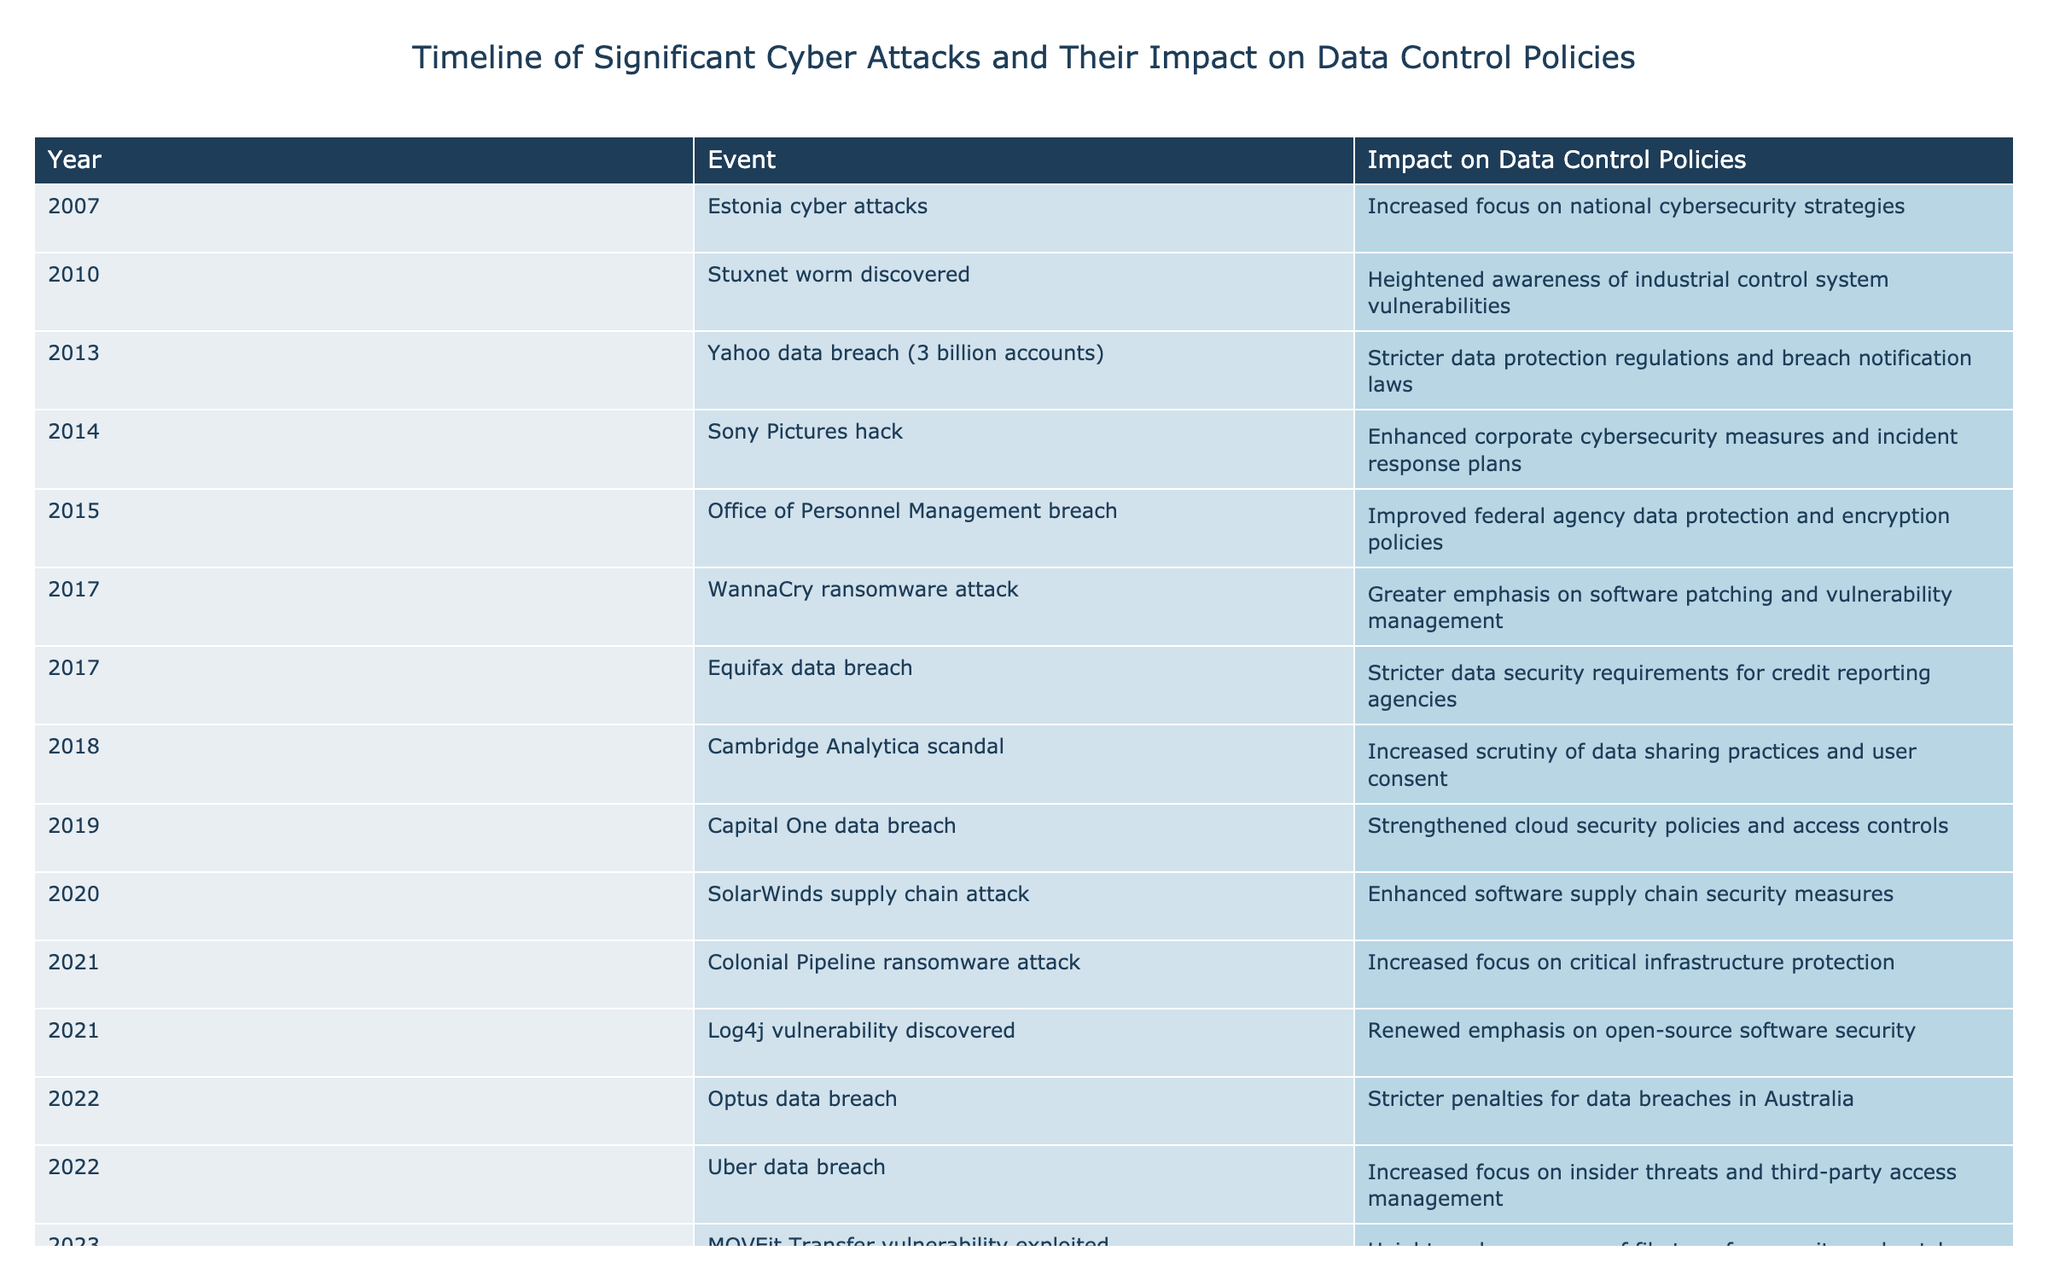What year did the Equifax data breach occur? The table directly lists the year associated with the Equifax data breach, which is 2017.
Answer: 2017 What impact did the Colonial Pipeline ransomware attack have on data control policies? The table states that the impact of the Colonial Pipeline ransomware attack in 2021 was an increased focus on critical infrastructure protection.
Answer: Increased focus on critical infrastructure protection Which event in 2018 led to increased scrutiny of data sharing practices? The table notes that the Cambridge Analytica scandal in 2018 is the event that led to increased scrutiny of data sharing practices and user consent.
Answer: Cambridge Analytica scandal How many events are listed for the year 2017? By counting the occurrences in the table, there are two events listed for 2017: the WannaCry ransomware attack and the Equifax data breach.
Answer: 2 Is there an event related to the improvement of encryption policies? Yes, the Office of Personnel Management breach in 2015 led to improved federal agency data protection and encryption policies according to the table.
Answer: Yes What were the impacts on data control policies from events occurring between 2014 and 2016? The impacts during this period include enhanced corporate cybersecurity measures (Sony Pictures hack, 2014), improved federal agency data protection and encryption policies (Office of Personnel Management breach, 2015), and stricter data protection regulations due to the Yahoo data breach (2013). Collectively, this showcases a growing recognition of the need for enhanced security and regulatory frameworks.
Answer: Enhanced security measures and stricter regulations Which attack prompted a heightened awareness of industrial control system vulnerabilities? According to the table, the Stuxnet worm discovered in 2010 prompted a heightened awareness of industrial control system vulnerabilities.
Answer: Stuxnet worm discovered What is the total number of significant cyber attack events listed from 2007 to 2023? Counting all rows of the table, there are 17 significant cyber attack events listed from 2007 to 2023.
Answer: 17 Were any data breaches in 2022 associated with increased focus on insider threats? Yes, the Uber data breach in 2022 is specifically noted for increasing focus on insider threats and third-party access management.
Answer: Yes 